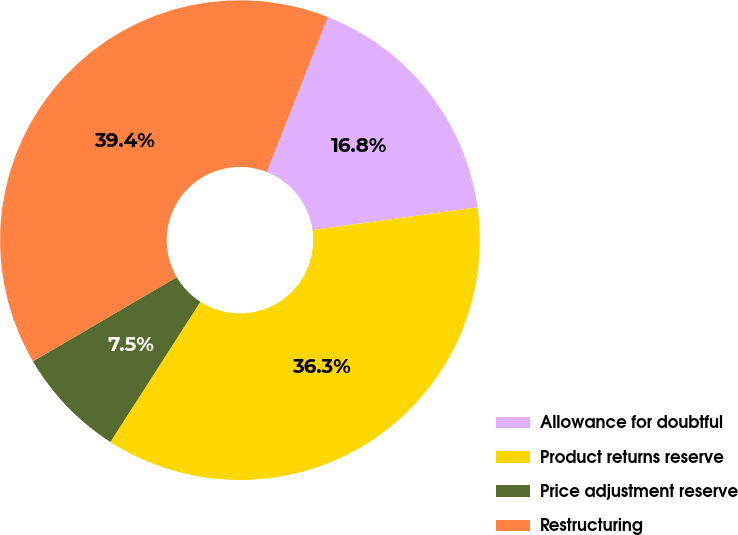Convert chart to OTSL. <chart><loc_0><loc_0><loc_500><loc_500><pie_chart><fcel>Allowance for doubtful<fcel>Product returns reserve<fcel>Price adjustment reserve<fcel>Restructuring<nl><fcel>16.84%<fcel>36.27%<fcel>7.49%<fcel>39.39%<nl></chart> 